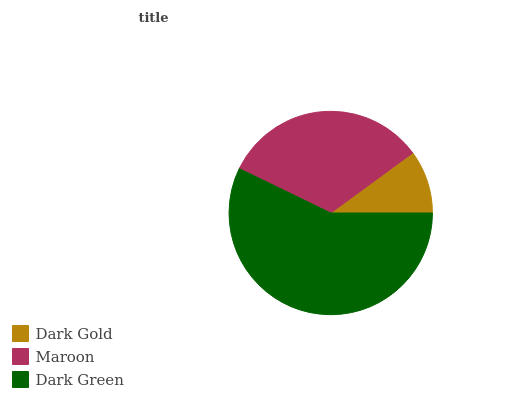Is Dark Gold the minimum?
Answer yes or no. Yes. Is Dark Green the maximum?
Answer yes or no. Yes. Is Maroon the minimum?
Answer yes or no. No. Is Maroon the maximum?
Answer yes or no. No. Is Maroon greater than Dark Gold?
Answer yes or no. Yes. Is Dark Gold less than Maroon?
Answer yes or no. Yes. Is Dark Gold greater than Maroon?
Answer yes or no. No. Is Maroon less than Dark Gold?
Answer yes or no. No. Is Maroon the high median?
Answer yes or no. Yes. Is Maroon the low median?
Answer yes or no. Yes. Is Dark Green the high median?
Answer yes or no. No. Is Dark Gold the low median?
Answer yes or no. No. 